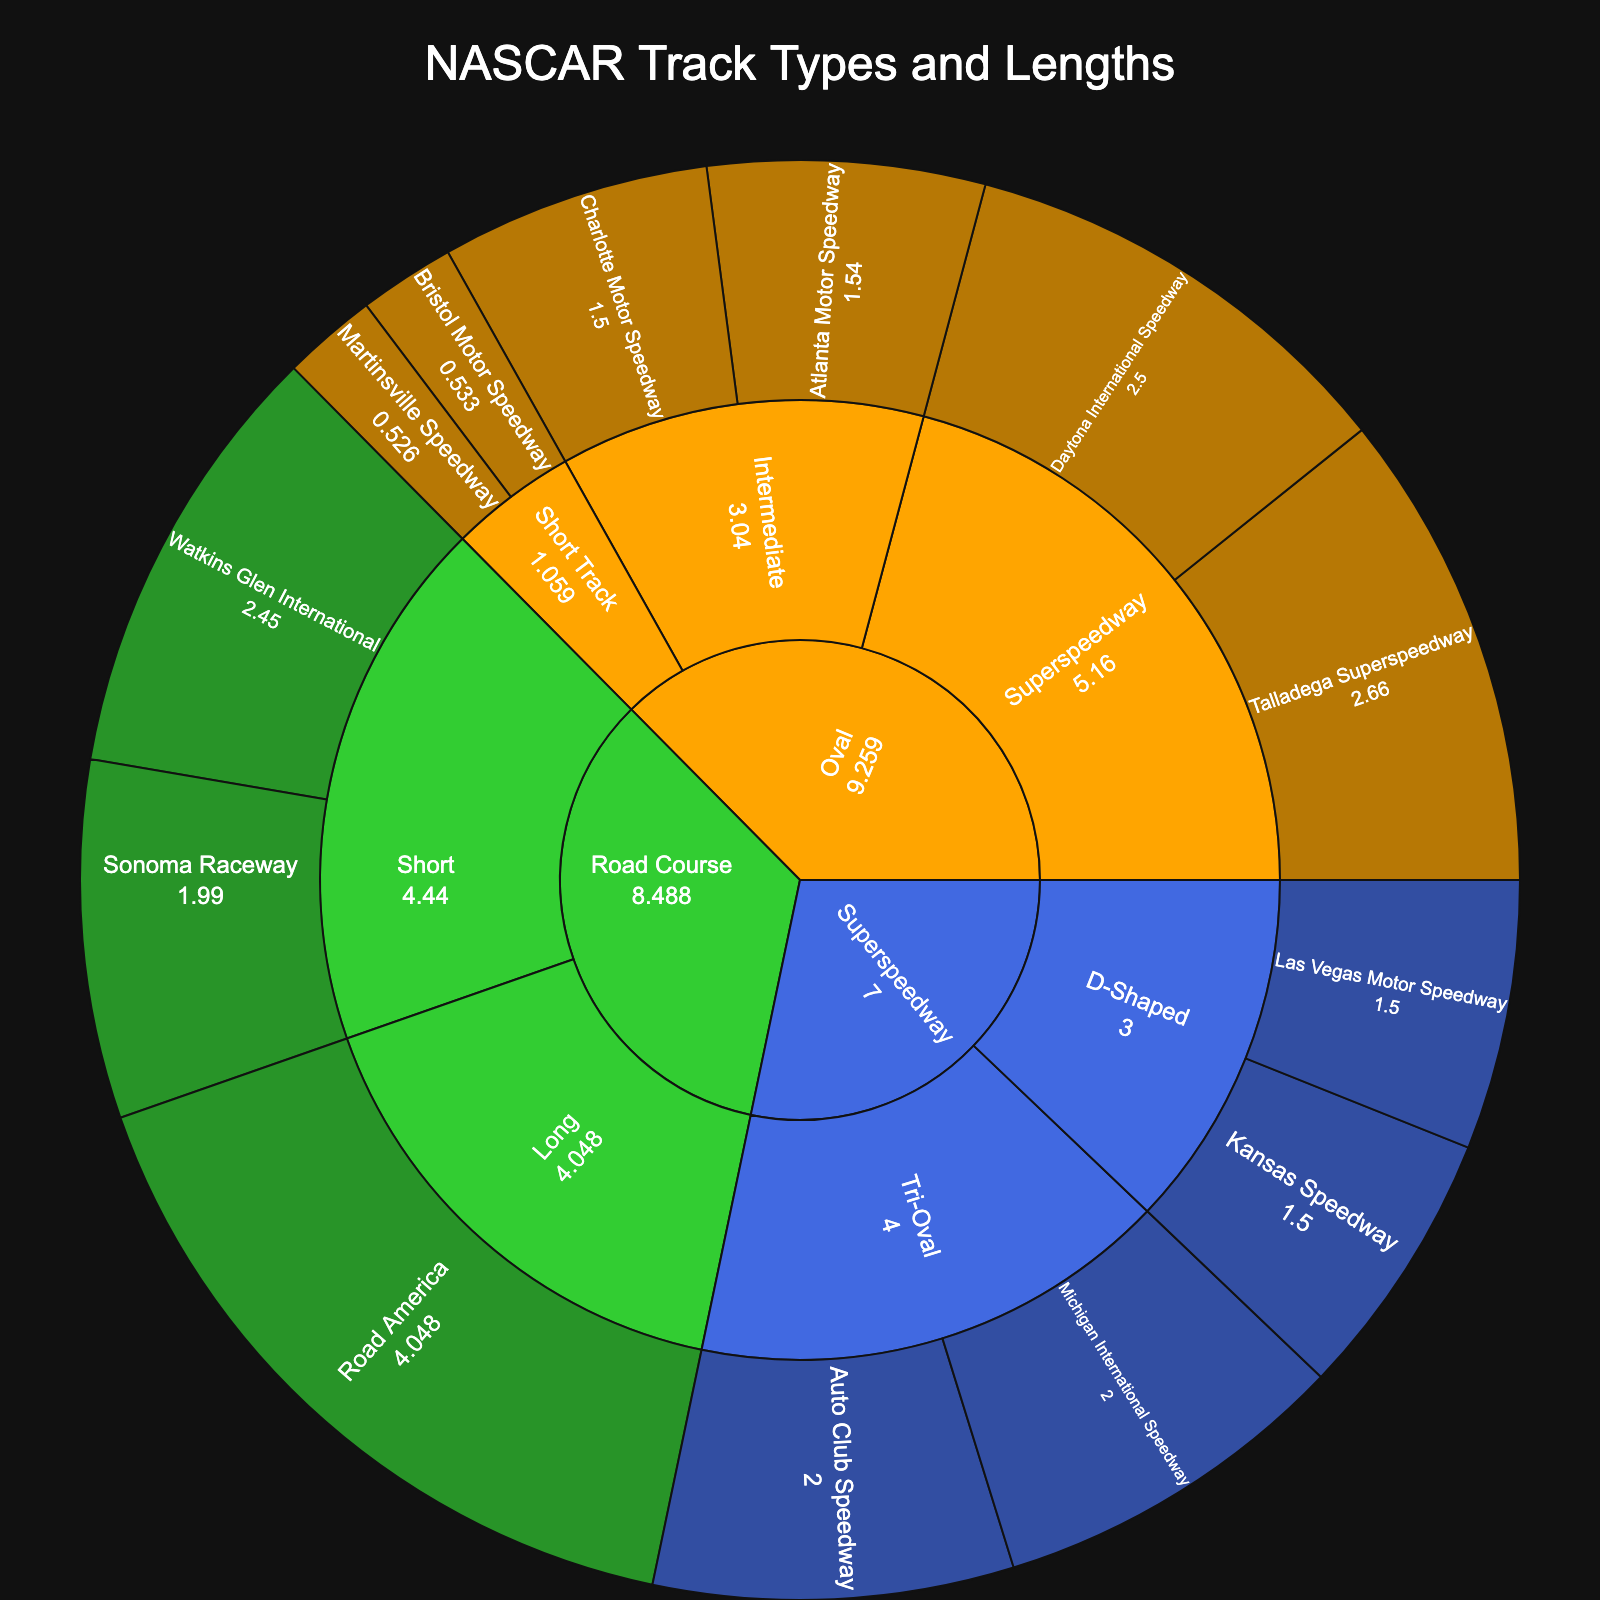What is the title of the plot? The title of a plot is usually displayed at the top, providing a brief description of what the plot represents. Here, it reads "NASCAR Track Types and Lengths".
Answer: NASCAR Track Types and Lengths What are the three main categories represented in the figure? The main categories in a sunburst plot are often displayed in the outermost colored segments. In this figure, these categories are "Oval", "Road Course", and "Superspeedway".
Answer: Oval, Road Course, Superspeedway Which track within the "Oval" category has the longest length? By inspecting the subcategories under "Oval", we identify the different tracks and their lengths. The "Superspeedway" subcategory within "Oval" includes tracks Daytona International Speedway (2.5 miles) and Talladega Superspeedway (2.66 miles), making Talladega Superspeedway the longest.
Answer: Talladega Superspeedway How many road course tracks are categorized as "Short"? By examining the "Road Course" category and identifying the "Short" subcategory, we see there are two tracks: Watkins Glen International and Sonoma Raceway.
Answer: 2 Compare the length of the Michigan International Speedway and Auto Club Speedway in the "Superspeedway" category. Which one is longer? Both Michigan International Speedway and Auto Club Speedway are listed under the "Tri-Oval" subcategory within "Superspeedway". According to the lengths provided, both tracks have a length of 2.0 miles, making them equal in length.
Answer: They are equal Sum the lengths of all tracks within the "Short Track" subcategory under "Oval". The "Short Track" subcategory contains Bristol Motor Speedway (0.533 miles) and Martinsville Speedway (0.526 miles). Summing these lengths results in 0.533 + 0.526 = 1.059 miles.
Answer: 1.059 miles Which subcategory under "Superspeedway" includes tracks with a length of 1.5 miles? By identifying subcategories and checking the track lengths, "D-Shaped" under "Superspeedway" includes Las Vegas Motor Speedway and Kansas Speedway, both having a length of 1.5 miles.
Answer: D-Shaped How many distinct subcategories are there under the "Oval" category? In the sunburst plot, the categories' subcategories are easily identifiable. Under "Oval", we observe "Short Track", "Intermediate", and "Superspeedway", giving us three distinct subcategories.
Answer: 3 What's the total length of all tracks in the "Road Course" category? Adding up the lengths of tracks under each subcategory of "Road Course": Watkins Glen International (2.45 miles), Sonoma Raceway (1.99 miles), and Road America (4.048 miles) amounts to 2.45 + 1.99 + 4.048 = 8.488 miles.
Answer: 8.488 miles 